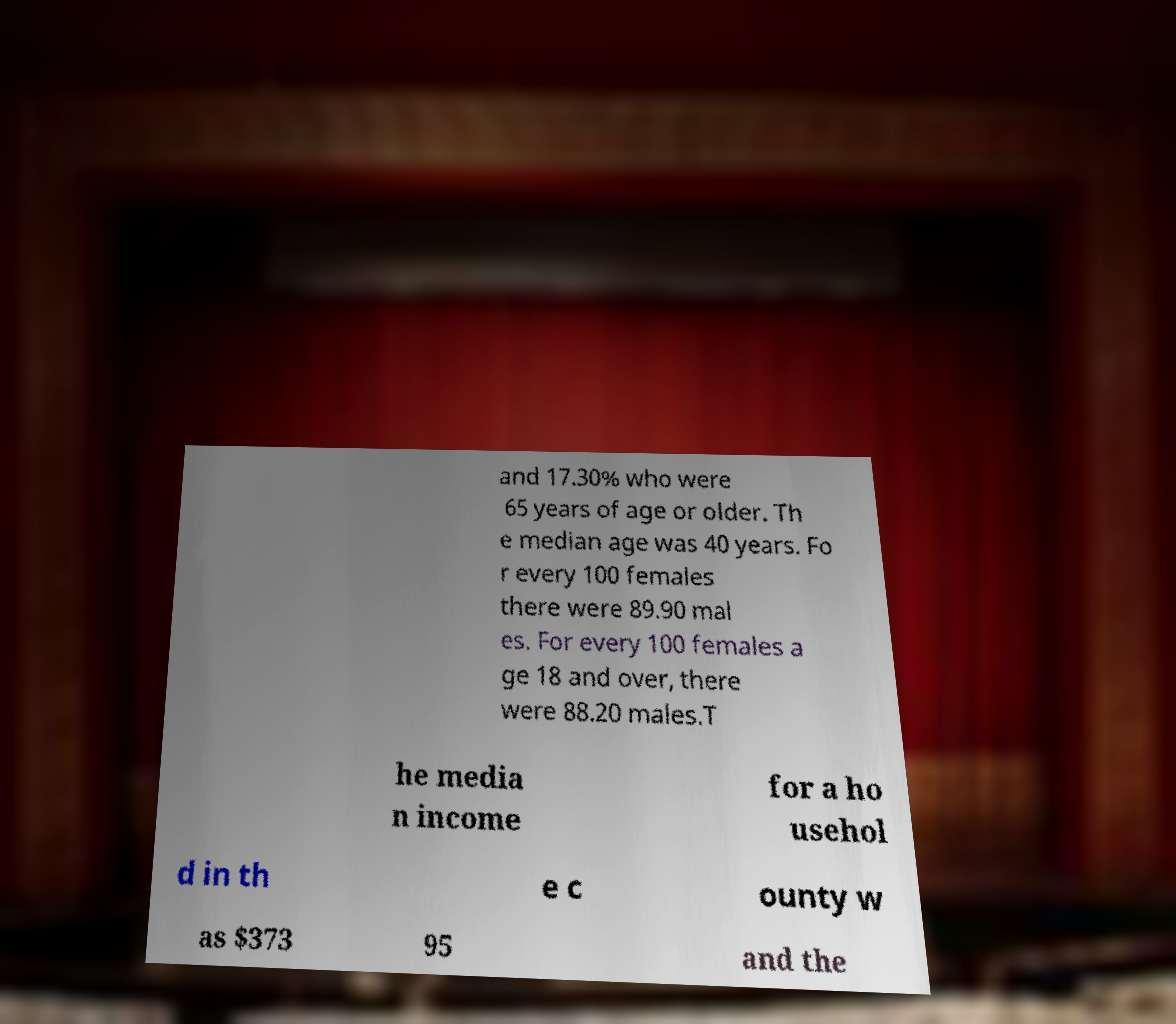I need the written content from this picture converted into text. Can you do that? and 17.30% who were 65 years of age or older. Th e median age was 40 years. Fo r every 100 females there were 89.90 mal es. For every 100 females a ge 18 and over, there were 88.20 males.T he media n income for a ho usehol d in th e c ounty w as $373 95 and the 